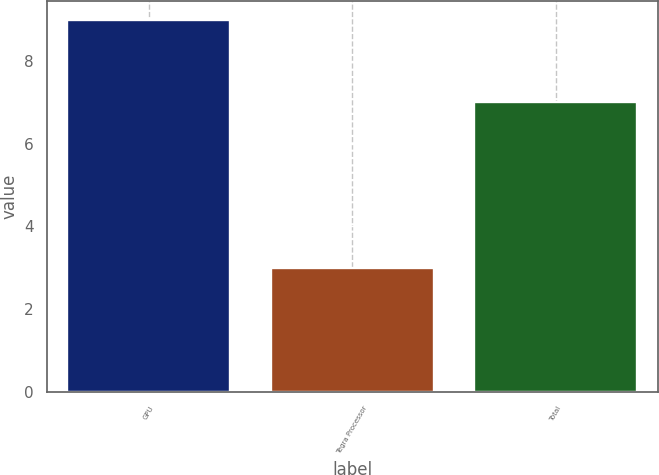<chart> <loc_0><loc_0><loc_500><loc_500><bar_chart><fcel>GPU<fcel>Tegra Processor<fcel>Total<nl><fcel>9<fcel>3<fcel>7<nl></chart> 